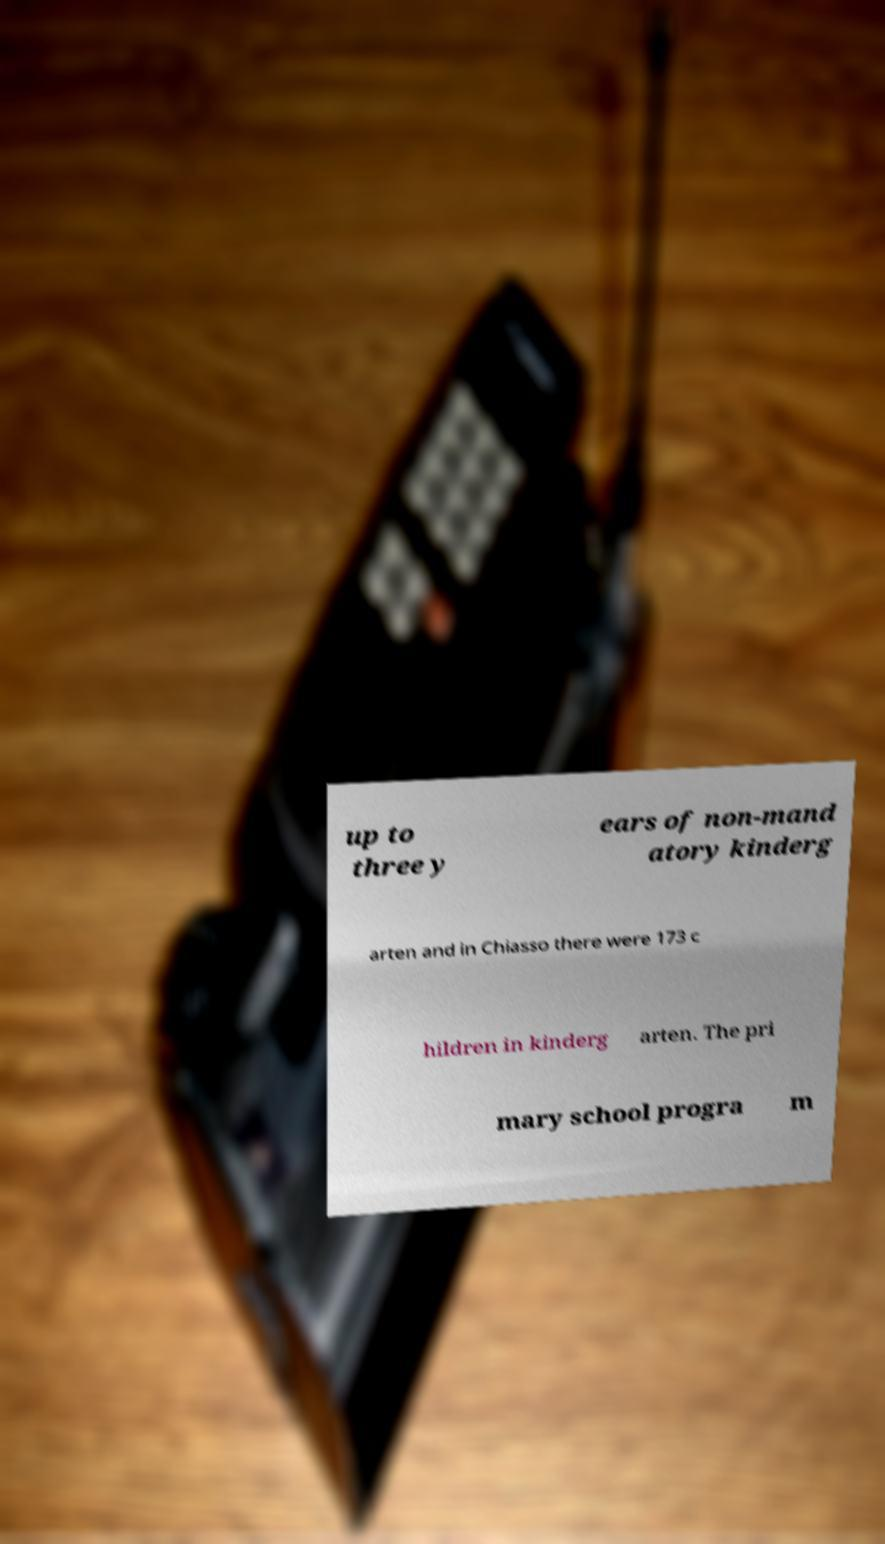There's text embedded in this image that I need extracted. Can you transcribe it verbatim? up to three y ears of non-mand atory kinderg arten and in Chiasso there were 173 c hildren in kinderg arten. The pri mary school progra m 